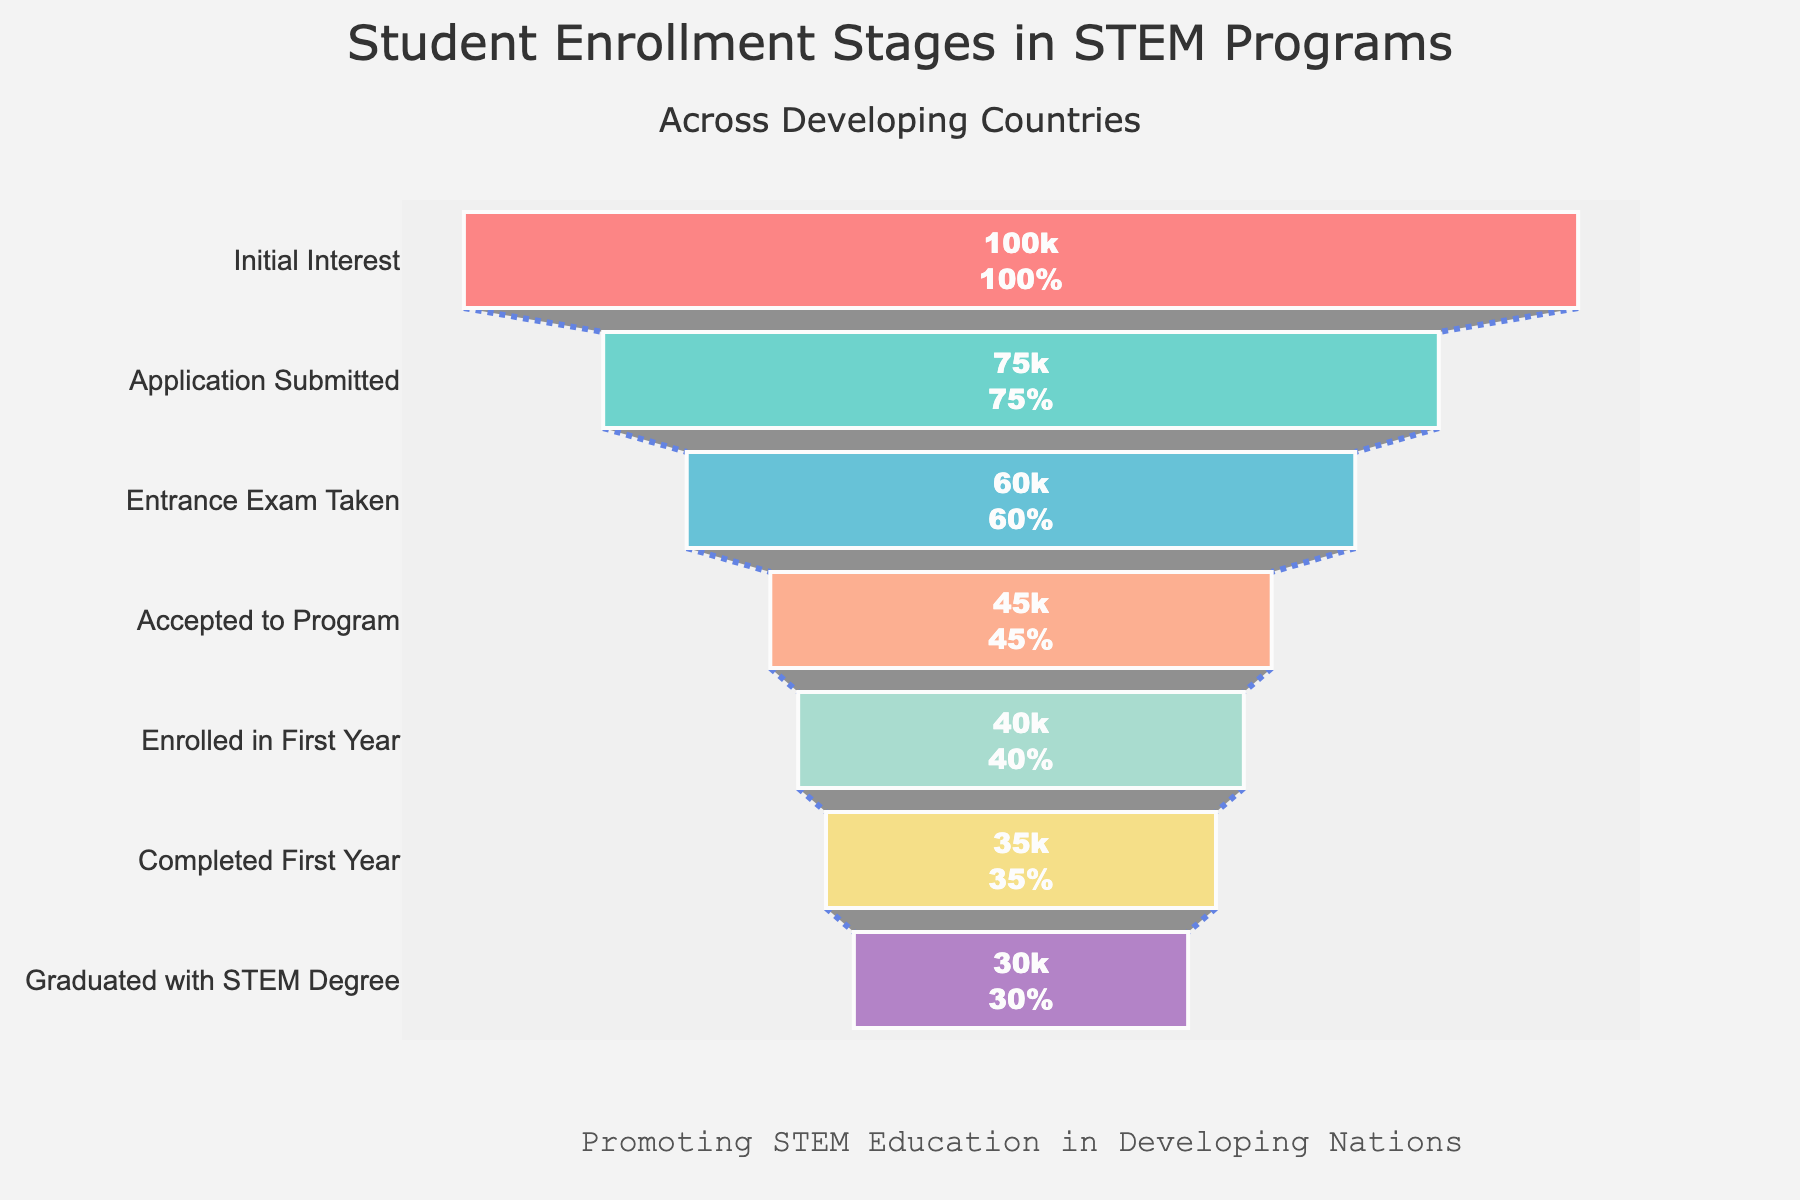What is the title of the figure? The title of the figure is given at the top and helps identify the overall topic.
Answer: Student Enrollment Stages in STEM Programs Which stage has the highest number of students? By looking at the funnel, the widest section represents the stage with the highest number.
Answer: Initial Interest How many students graduated with a STEM degree? The number of students at the final stage of the funnel shows this information.
Answer: 30000 How many more students enrolled in the first year than completed the first year? Subtract the number of students who completed the first year from those who enrolled in it. 40000 - 35000
Answer: 5000 What percentage of students who took the entrance exam were accepted to the program? Divide the number of students accepted by those who took the exam and multiply by 100 to get the percentage. (45000 / 60000) * 100
Answer: 75% Which stage shows the biggest drop in the number of students compared to the previous stage? By examining the differences between consecutive stages, the largest decrease can be identified.
Answer: Application Submitted to Entrance Exam Taken Compare the number of students who submitted an application to those who graduated with a STEM degree. Subtract the number of students who graduated from the number who submitted an application. 75000 - 30000
Answer: 45000 What is the overall retention rate from initial interest to graduation? Divide the number of graduated students by the number of students with initial interest and multiply by 100 to get the percentage. (30000 / 100000) * 100
Answer: 30% How many students were not accepted to the program after taking the entrance exam? Subtract the number of accepted students from those who took the entrance exam. 60000 - 45000
Answer: 15000 What color represents the "Enrolled in First Year" stage in the funnel chart? Each stage in the funnel chart is represented by a different color. Find the specific color for the desired stage.
Answer: #98D8C8 